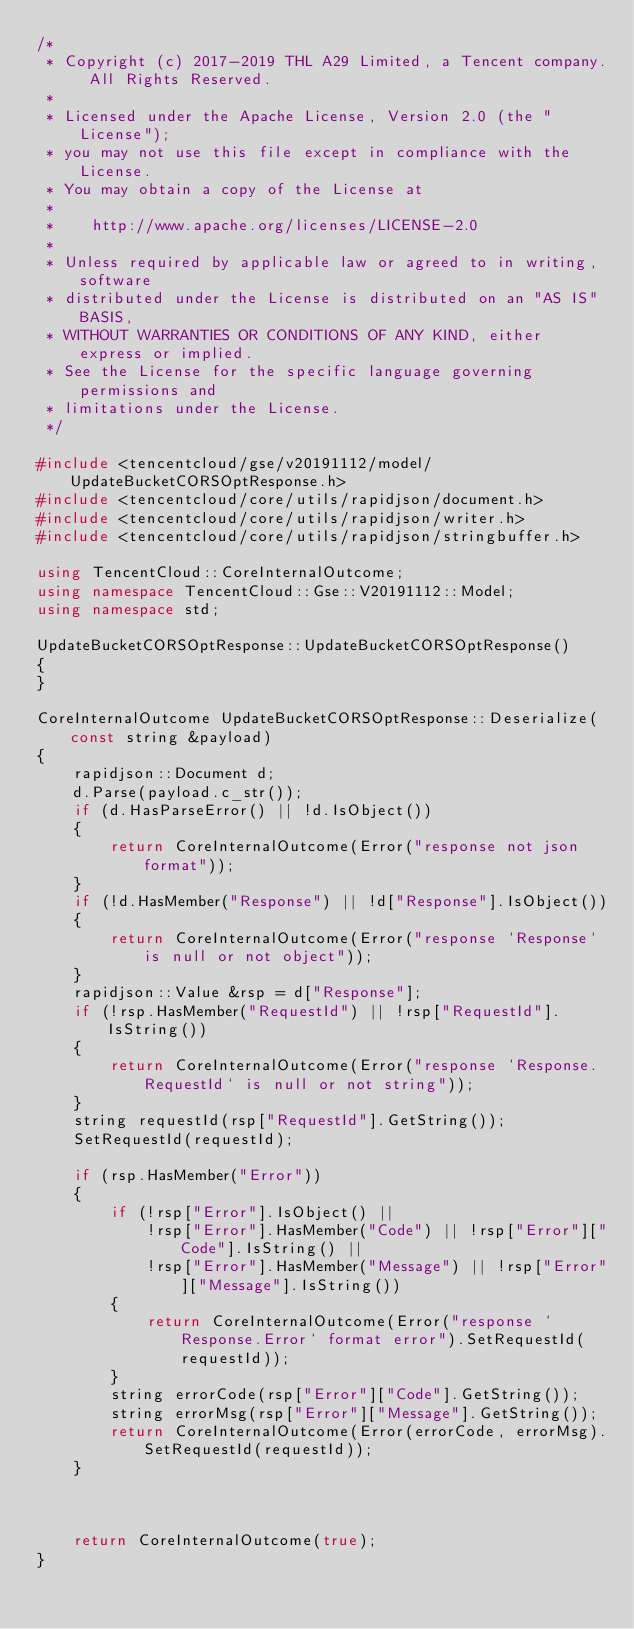Convert code to text. <code><loc_0><loc_0><loc_500><loc_500><_C++_>/*
 * Copyright (c) 2017-2019 THL A29 Limited, a Tencent company. All Rights Reserved.
 *
 * Licensed under the Apache License, Version 2.0 (the "License");
 * you may not use this file except in compliance with the License.
 * You may obtain a copy of the License at
 *
 *    http://www.apache.org/licenses/LICENSE-2.0
 *
 * Unless required by applicable law or agreed to in writing, software
 * distributed under the License is distributed on an "AS IS" BASIS,
 * WITHOUT WARRANTIES OR CONDITIONS OF ANY KIND, either express or implied.
 * See the License for the specific language governing permissions and
 * limitations under the License.
 */

#include <tencentcloud/gse/v20191112/model/UpdateBucketCORSOptResponse.h>
#include <tencentcloud/core/utils/rapidjson/document.h>
#include <tencentcloud/core/utils/rapidjson/writer.h>
#include <tencentcloud/core/utils/rapidjson/stringbuffer.h>

using TencentCloud::CoreInternalOutcome;
using namespace TencentCloud::Gse::V20191112::Model;
using namespace std;

UpdateBucketCORSOptResponse::UpdateBucketCORSOptResponse()
{
}

CoreInternalOutcome UpdateBucketCORSOptResponse::Deserialize(const string &payload)
{
    rapidjson::Document d;
    d.Parse(payload.c_str());
    if (d.HasParseError() || !d.IsObject())
    {
        return CoreInternalOutcome(Error("response not json format"));
    }
    if (!d.HasMember("Response") || !d["Response"].IsObject())
    {
        return CoreInternalOutcome(Error("response `Response` is null or not object"));
    }
    rapidjson::Value &rsp = d["Response"];
    if (!rsp.HasMember("RequestId") || !rsp["RequestId"].IsString())
    {
        return CoreInternalOutcome(Error("response `Response.RequestId` is null or not string"));
    }
    string requestId(rsp["RequestId"].GetString());
    SetRequestId(requestId);

    if (rsp.HasMember("Error"))
    {
        if (!rsp["Error"].IsObject() ||
            !rsp["Error"].HasMember("Code") || !rsp["Error"]["Code"].IsString() ||
            !rsp["Error"].HasMember("Message") || !rsp["Error"]["Message"].IsString())
        {
            return CoreInternalOutcome(Error("response `Response.Error` format error").SetRequestId(requestId));
        }
        string errorCode(rsp["Error"]["Code"].GetString());
        string errorMsg(rsp["Error"]["Message"].GetString());
        return CoreInternalOutcome(Error(errorCode, errorMsg).SetRequestId(requestId));
    }



    return CoreInternalOutcome(true);
}



</code> 